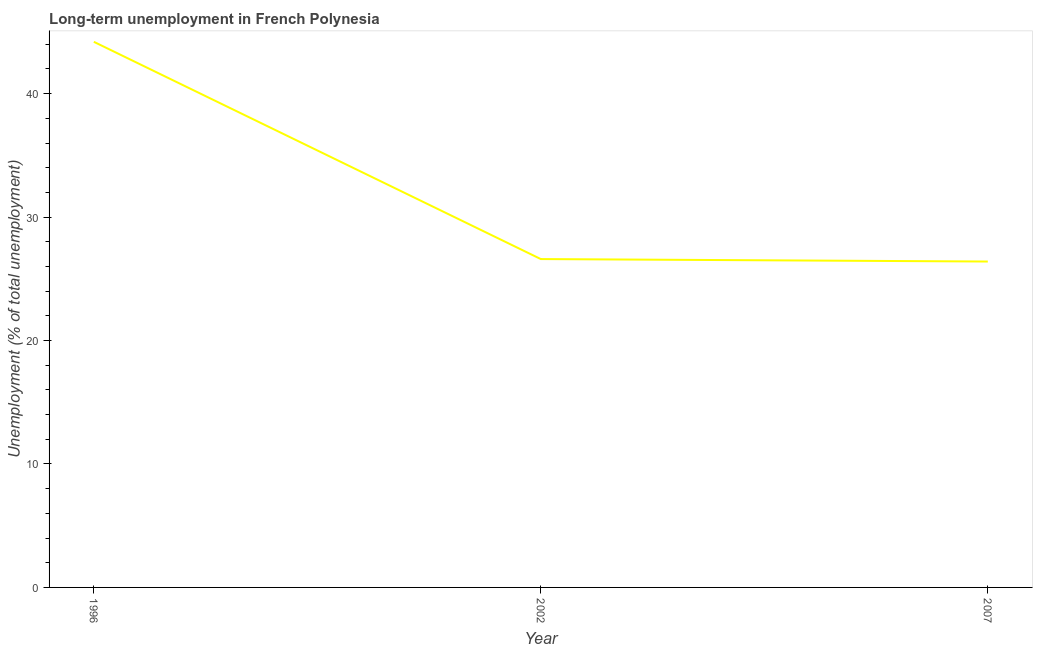What is the long-term unemployment in 1996?
Your answer should be compact. 44.2. Across all years, what is the maximum long-term unemployment?
Offer a very short reply. 44.2. Across all years, what is the minimum long-term unemployment?
Your answer should be compact. 26.4. In which year was the long-term unemployment maximum?
Keep it short and to the point. 1996. What is the sum of the long-term unemployment?
Provide a short and direct response. 97.2. What is the difference between the long-term unemployment in 2002 and 2007?
Your response must be concise. 0.2. What is the average long-term unemployment per year?
Make the answer very short. 32.4. What is the median long-term unemployment?
Your answer should be very brief. 26.6. Do a majority of the years between 1996 and 2002 (inclusive) have long-term unemployment greater than 4 %?
Make the answer very short. Yes. What is the ratio of the long-term unemployment in 1996 to that in 2002?
Provide a succinct answer. 1.66. Is the long-term unemployment in 1996 less than that in 2002?
Offer a terse response. No. Is the difference between the long-term unemployment in 1996 and 2002 greater than the difference between any two years?
Ensure brevity in your answer.  No. What is the difference between the highest and the second highest long-term unemployment?
Provide a succinct answer. 17.6. Is the sum of the long-term unemployment in 1996 and 2002 greater than the maximum long-term unemployment across all years?
Provide a succinct answer. Yes. What is the difference between the highest and the lowest long-term unemployment?
Keep it short and to the point. 17.8. What is the title of the graph?
Make the answer very short. Long-term unemployment in French Polynesia. What is the label or title of the X-axis?
Keep it short and to the point. Year. What is the label or title of the Y-axis?
Offer a very short reply. Unemployment (% of total unemployment). What is the Unemployment (% of total unemployment) in 1996?
Offer a terse response. 44.2. What is the Unemployment (% of total unemployment) of 2002?
Give a very brief answer. 26.6. What is the Unemployment (% of total unemployment) in 2007?
Offer a very short reply. 26.4. What is the difference between the Unemployment (% of total unemployment) in 1996 and 2002?
Ensure brevity in your answer.  17.6. What is the difference between the Unemployment (% of total unemployment) in 2002 and 2007?
Offer a very short reply. 0.2. What is the ratio of the Unemployment (% of total unemployment) in 1996 to that in 2002?
Your response must be concise. 1.66. What is the ratio of the Unemployment (% of total unemployment) in 1996 to that in 2007?
Your response must be concise. 1.67. 